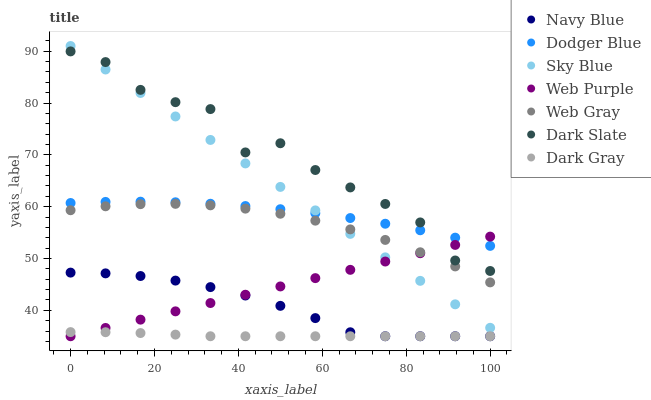Does Dark Gray have the minimum area under the curve?
Answer yes or no. Yes. Does Dark Slate have the maximum area under the curve?
Answer yes or no. Yes. Does Navy Blue have the minimum area under the curve?
Answer yes or no. No. Does Navy Blue have the maximum area under the curve?
Answer yes or no. No. Is Web Purple the smoothest?
Answer yes or no. Yes. Is Dark Slate the roughest?
Answer yes or no. Yes. Is Navy Blue the smoothest?
Answer yes or no. No. Is Navy Blue the roughest?
Answer yes or no. No. Does Navy Blue have the lowest value?
Answer yes or no. Yes. Does Dark Slate have the lowest value?
Answer yes or no. No. Does Sky Blue have the highest value?
Answer yes or no. Yes. Does Navy Blue have the highest value?
Answer yes or no. No. Is Navy Blue less than Dodger Blue?
Answer yes or no. Yes. Is Dark Slate greater than Navy Blue?
Answer yes or no. Yes. Does Navy Blue intersect Web Purple?
Answer yes or no. Yes. Is Navy Blue less than Web Purple?
Answer yes or no. No. Is Navy Blue greater than Web Purple?
Answer yes or no. No. Does Navy Blue intersect Dodger Blue?
Answer yes or no. No. 